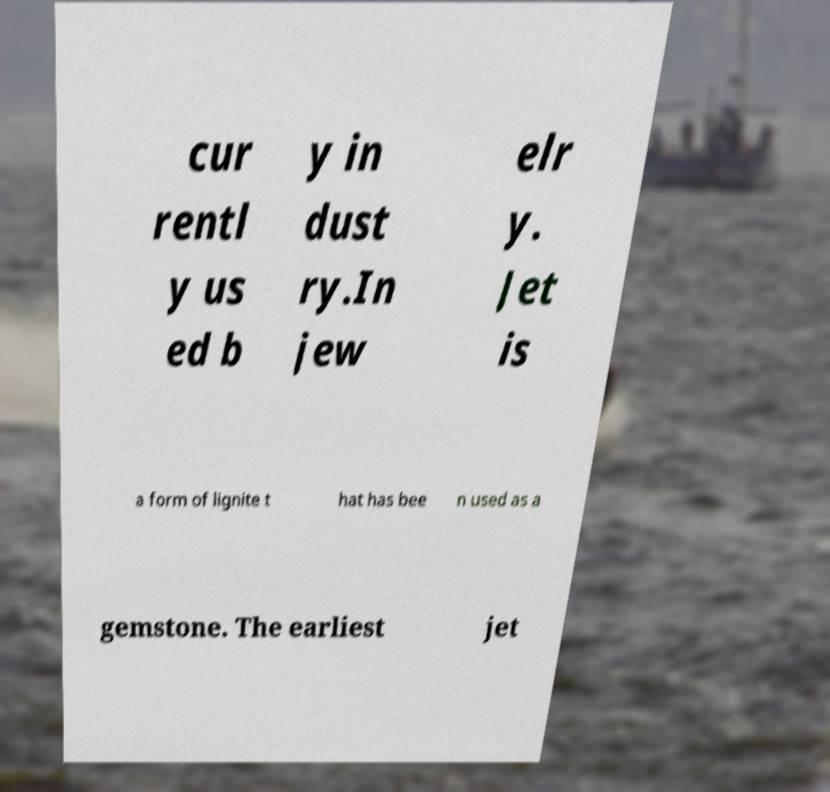Can you read and provide the text displayed in the image?This photo seems to have some interesting text. Can you extract and type it out for me? cur rentl y us ed b y in dust ry.In jew elr y. Jet is a form of lignite t hat has bee n used as a gemstone. The earliest jet 